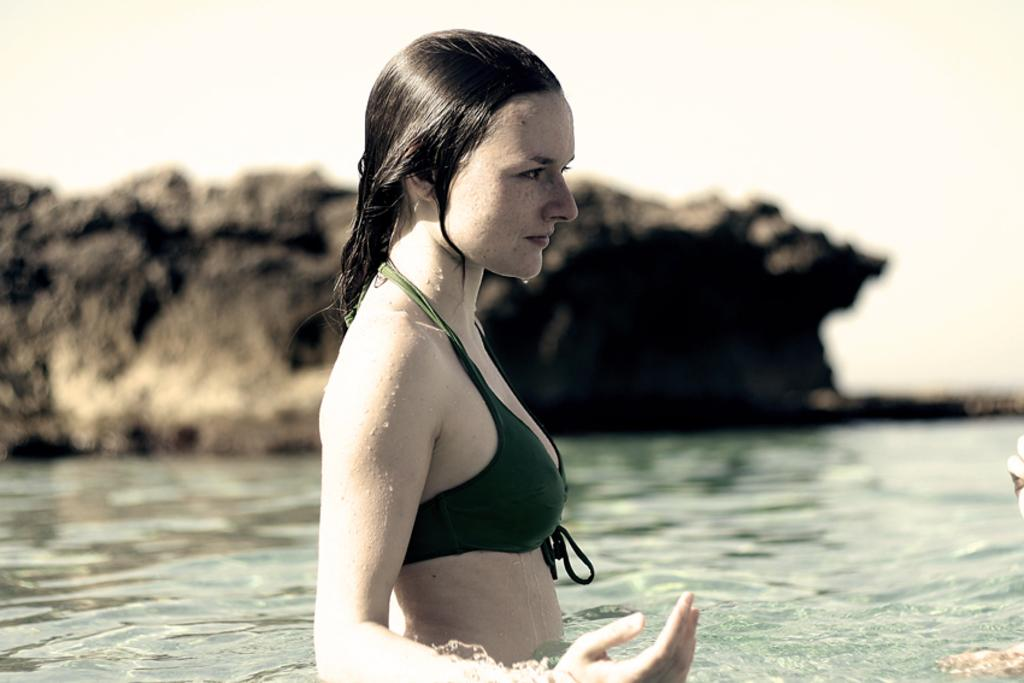What is the lady doing in the image? The lady is in the water. What can be seen in the background of the image? There is a stone in the background of the image. How is the stone depicted in the image? The stone appears to be blurred. How does the lady's brother in the image? There is no mention of a brother or assistance in the image, so this question cannot be answered. 